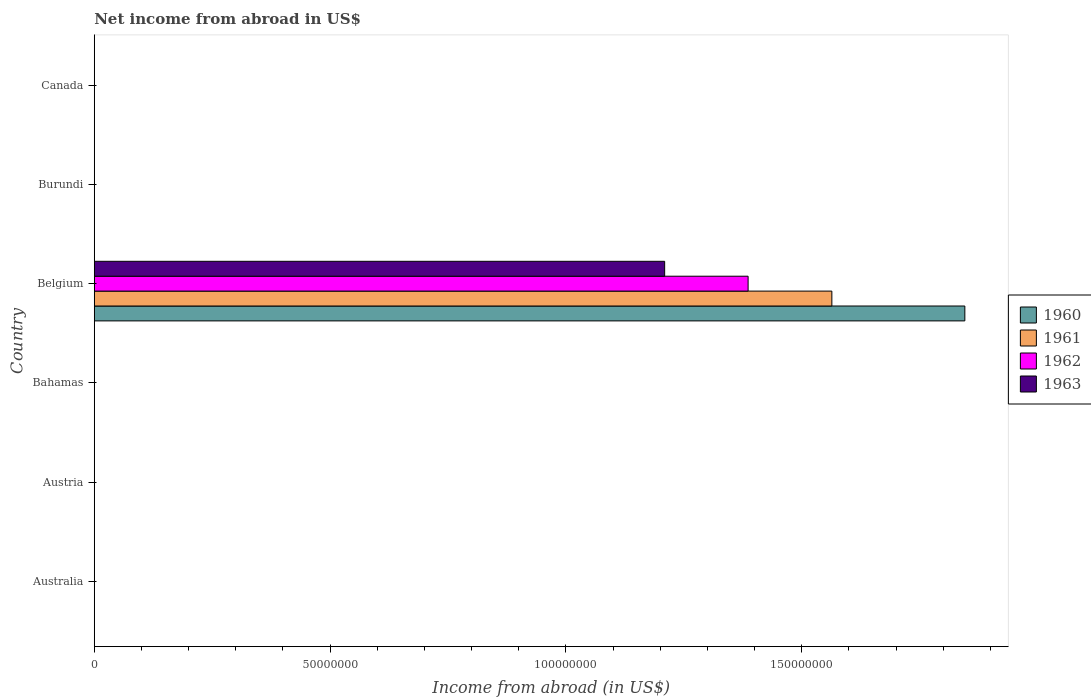How many different coloured bars are there?
Offer a terse response. 4. Are the number of bars per tick equal to the number of legend labels?
Offer a terse response. No. How many bars are there on the 1st tick from the top?
Ensure brevity in your answer.  0. What is the label of the 4th group of bars from the top?
Offer a very short reply. Bahamas. In how many cases, is the number of bars for a given country not equal to the number of legend labels?
Your answer should be compact. 5. What is the net income from abroad in 1960 in Belgium?
Your answer should be very brief. 1.85e+08. Across all countries, what is the maximum net income from abroad in 1962?
Your response must be concise. 1.39e+08. Across all countries, what is the minimum net income from abroad in 1960?
Make the answer very short. 0. What is the total net income from abroad in 1961 in the graph?
Your answer should be compact. 1.56e+08. What is the difference between the net income from abroad in 1961 in Bahamas and the net income from abroad in 1962 in Belgium?
Provide a short and direct response. -1.39e+08. What is the average net income from abroad in 1963 per country?
Your answer should be compact. 2.02e+07. What is the difference between the net income from abroad in 1960 and net income from abroad in 1962 in Belgium?
Your response must be concise. 4.60e+07. What is the difference between the highest and the lowest net income from abroad in 1963?
Offer a terse response. 1.21e+08. In how many countries, is the net income from abroad in 1960 greater than the average net income from abroad in 1960 taken over all countries?
Give a very brief answer. 1. Is it the case that in every country, the sum of the net income from abroad in 1962 and net income from abroad in 1960 is greater than the sum of net income from abroad in 1963 and net income from abroad in 1961?
Ensure brevity in your answer.  No. Are all the bars in the graph horizontal?
Give a very brief answer. Yes. Does the graph contain grids?
Ensure brevity in your answer.  No. How many legend labels are there?
Give a very brief answer. 4. How are the legend labels stacked?
Provide a succinct answer. Vertical. What is the title of the graph?
Your response must be concise. Net income from abroad in US$. Does "1965" appear as one of the legend labels in the graph?
Ensure brevity in your answer.  No. What is the label or title of the X-axis?
Your answer should be very brief. Income from abroad (in US$). What is the Income from abroad (in US$) in 1961 in Australia?
Your answer should be compact. 0. What is the Income from abroad (in US$) of 1960 in Austria?
Give a very brief answer. 0. What is the Income from abroad (in US$) in 1961 in Austria?
Your answer should be compact. 0. What is the Income from abroad (in US$) in 1963 in Austria?
Give a very brief answer. 0. What is the Income from abroad (in US$) in 1961 in Bahamas?
Provide a succinct answer. 0. What is the Income from abroad (in US$) of 1963 in Bahamas?
Provide a short and direct response. 0. What is the Income from abroad (in US$) of 1960 in Belgium?
Keep it short and to the point. 1.85e+08. What is the Income from abroad (in US$) of 1961 in Belgium?
Make the answer very short. 1.56e+08. What is the Income from abroad (in US$) in 1962 in Belgium?
Make the answer very short. 1.39e+08. What is the Income from abroad (in US$) in 1963 in Belgium?
Ensure brevity in your answer.  1.21e+08. What is the Income from abroad (in US$) in 1960 in Canada?
Offer a very short reply. 0. What is the Income from abroad (in US$) of 1962 in Canada?
Keep it short and to the point. 0. What is the Income from abroad (in US$) in 1963 in Canada?
Offer a terse response. 0. Across all countries, what is the maximum Income from abroad (in US$) of 1960?
Provide a succinct answer. 1.85e+08. Across all countries, what is the maximum Income from abroad (in US$) in 1961?
Your answer should be compact. 1.56e+08. Across all countries, what is the maximum Income from abroad (in US$) of 1962?
Your answer should be compact. 1.39e+08. Across all countries, what is the maximum Income from abroad (in US$) in 1963?
Give a very brief answer. 1.21e+08. Across all countries, what is the minimum Income from abroad (in US$) in 1961?
Make the answer very short. 0. What is the total Income from abroad (in US$) of 1960 in the graph?
Offer a very short reply. 1.85e+08. What is the total Income from abroad (in US$) of 1961 in the graph?
Your answer should be compact. 1.56e+08. What is the total Income from abroad (in US$) of 1962 in the graph?
Provide a succinct answer. 1.39e+08. What is the total Income from abroad (in US$) in 1963 in the graph?
Offer a very short reply. 1.21e+08. What is the average Income from abroad (in US$) in 1960 per country?
Your response must be concise. 3.08e+07. What is the average Income from abroad (in US$) of 1961 per country?
Your response must be concise. 2.61e+07. What is the average Income from abroad (in US$) of 1962 per country?
Provide a short and direct response. 2.31e+07. What is the average Income from abroad (in US$) in 1963 per country?
Your answer should be compact. 2.02e+07. What is the difference between the Income from abroad (in US$) of 1960 and Income from abroad (in US$) of 1961 in Belgium?
Your response must be concise. 2.82e+07. What is the difference between the Income from abroad (in US$) of 1960 and Income from abroad (in US$) of 1962 in Belgium?
Provide a short and direct response. 4.60e+07. What is the difference between the Income from abroad (in US$) in 1960 and Income from abroad (in US$) in 1963 in Belgium?
Ensure brevity in your answer.  6.37e+07. What is the difference between the Income from abroad (in US$) of 1961 and Income from abroad (in US$) of 1962 in Belgium?
Your answer should be compact. 1.78e+07. What is the difference between the Income from abroad (in US$) in 1961 and Income from abroad (in US$) in 1963 in Belgium?
Ensure brevity in your answer.  3.55e+07. What is the difference between the Income from abroad (in US$) in 1962 and Income from abroad (in US$) in 1963 in Belgium?
Provide a succinct answer. 1.77e+07. What is the difference between the highest and the lowest Income from abroad (in US$) of 1960?
Keep it short and to the point. 1.85e+08. What is the difference between the highest and the lowest Income from abroad (in US$) in 1961?
Offer a terse response. 1.56e+08. What is the difference between the highest and the lowest Income from abroad (in US$) of 1962?
Keep it short and to the point. 1.39e+08. What is the difference between the highest and the lowest Income from abroad (in US$) of 1963?
Make the answer very short. 1.21e+08. 